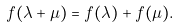Convert formula to latex. <formula><loc_0><loc_0><loc_500><loc_500>f ( \lambda + \mu ) = f ( \lambda ) + f ( \mu ) .</formula> 